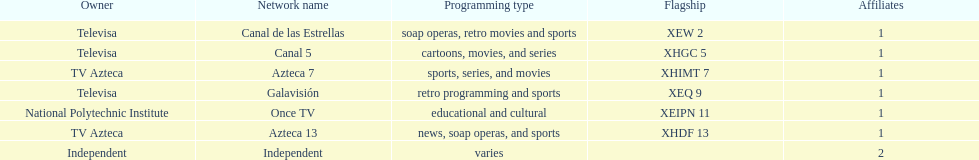Give me the full table as a dictionary. {'header': ['Owner', 'Network name', 'Programming type', 'Flagship', 'Affiliates'], 'rows': [['Televisa', 'Canal de las Estrellas', 'soap operas, retro movies and sports', 'XEW 2', '1'], ['Televisa', 'Canal 5', 'cartoons, movies, and series', 'XHGC 5', '1'], ['TV Azteca', 'Azteca 7', 'sports, series, and movies', 'XHIMT 7', '1'], ['Televisa', 'Galavisión', 'retro programming and sports', 'XEQ 9', '1'], ['National Polytechnic Institute', 'Once TV', 'educational and cultural', 'XEIPN 11', '1'], ['TV Azteca', 'Azteca 13', 'news, soap operas, and sports', 'XHDF 13', '1'], ['Independent', 'Independent', 'varies', '', '2']]} What is the number of networks that are owned by televisa? 3. 